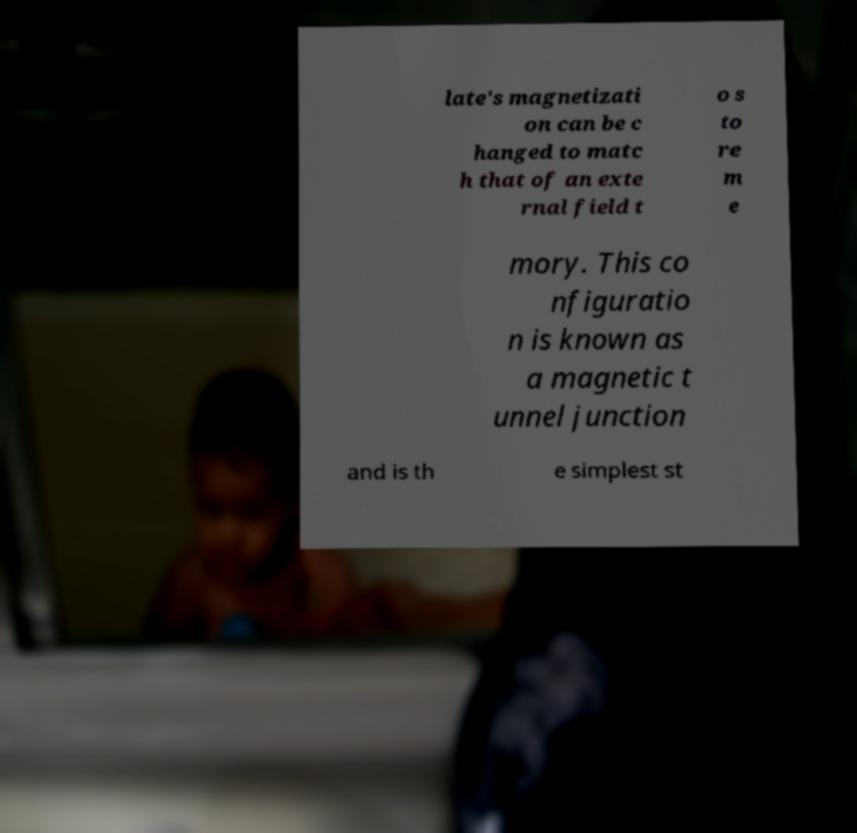Could you assist in decoding the text presented in this image and type it out clearly? late's magnetizati on can be c hanged to matc h that of an exte rnal field t o s to re m e mory. This co nfiguratio n is known as a magnetic t unnel junction and is th e simplest st 